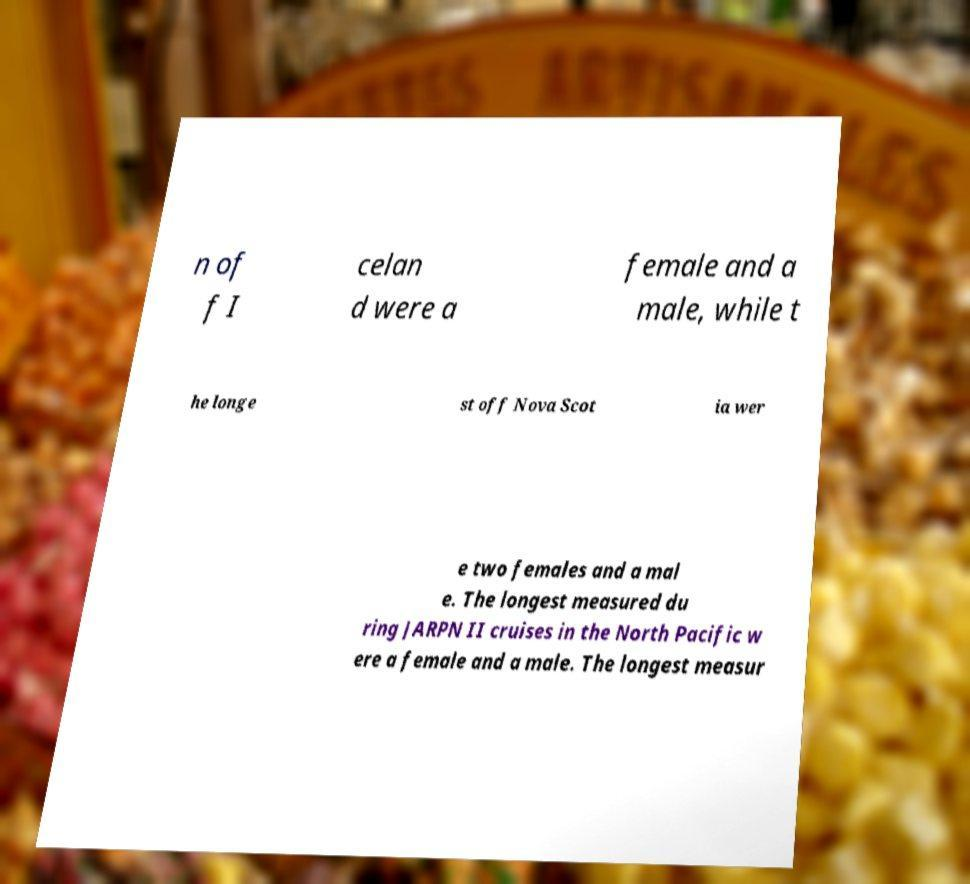Could you assist in decoding the text presented in this image and type it out clearly? n of f I celan d were a female and a male, while t he longe st off Nova Scot ia wer e two females and a mal e. The longest measured du ring JARPN II cruises in the North Pacific w ere a female and a male. The longest measur 